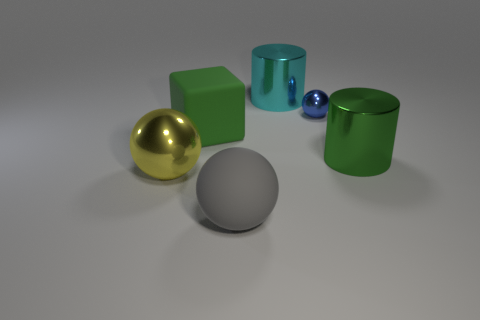Subtract all shiny spheres. How many spheres are left? 1 Add 2 large cyan metal things. How many objects exist? 8 Subtract all yellow spheres. How many spheres are left? 2 Subtract all blocks. How many objects are left? 5 Subtract 1 blocks. How many blocks are left? 0 Subtract all green balls. Subtract all cyan cubes. How many balls are left? 3 Subtract all big cyan shiny things. Subtract all big red rubber cylinders. How many objects are left? 5 Add 3 big cylinders. How many big cylinders are left? 5 Add 6 tiny yellow rubber objects. How many tiny yellow rubber objects exist? 6 Subtract 0 cyan cubes. How many objects are left? 6 